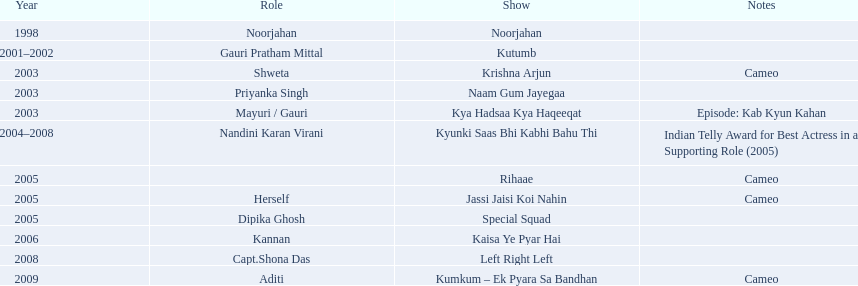How many shows are there? Noorjahan, Kutumb, Krishna Arjun, Naam Gum Jayegaa, Kya Hadsaa Kya Haqeeqat, Kyunki Saas Bhi Kabhi Bahu Thi, Rihaae, Jassi Jaisi Koi Nahin, Special Squad, Kaisa Ye Pyar Hai, Left Right Left, Kumkum – Ek Pyara Sa Bandhan. How many shows did she make a cameo appearance? Krishna Arjun, Rihaae, Jassi Jaisi Koi Nahin, Kumkum – Ek Pyara Sa Bandhan. Of those, how many did she play herself? Jassi Jaisi Koi Nahin. 